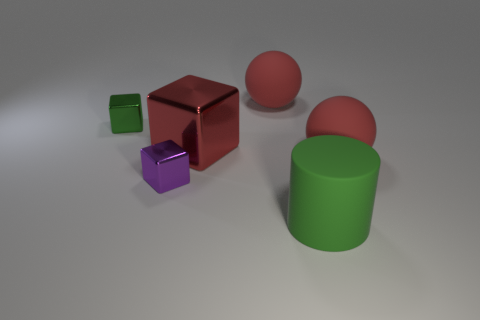Add 1 small purple blocks. How many objects exist? 7 Subtract all spheres. How many objects are left? 4 Add 1 green matte cylinders. How many green matte cylinders are left? 2 Add 2 cylinders. How many cylinders exist? 3 Subtract 0 brown blocks. How many objects are left? 6 Subtract all large red rubber cubes. Subtract all green shiny blocks. How many objects are left? 5 